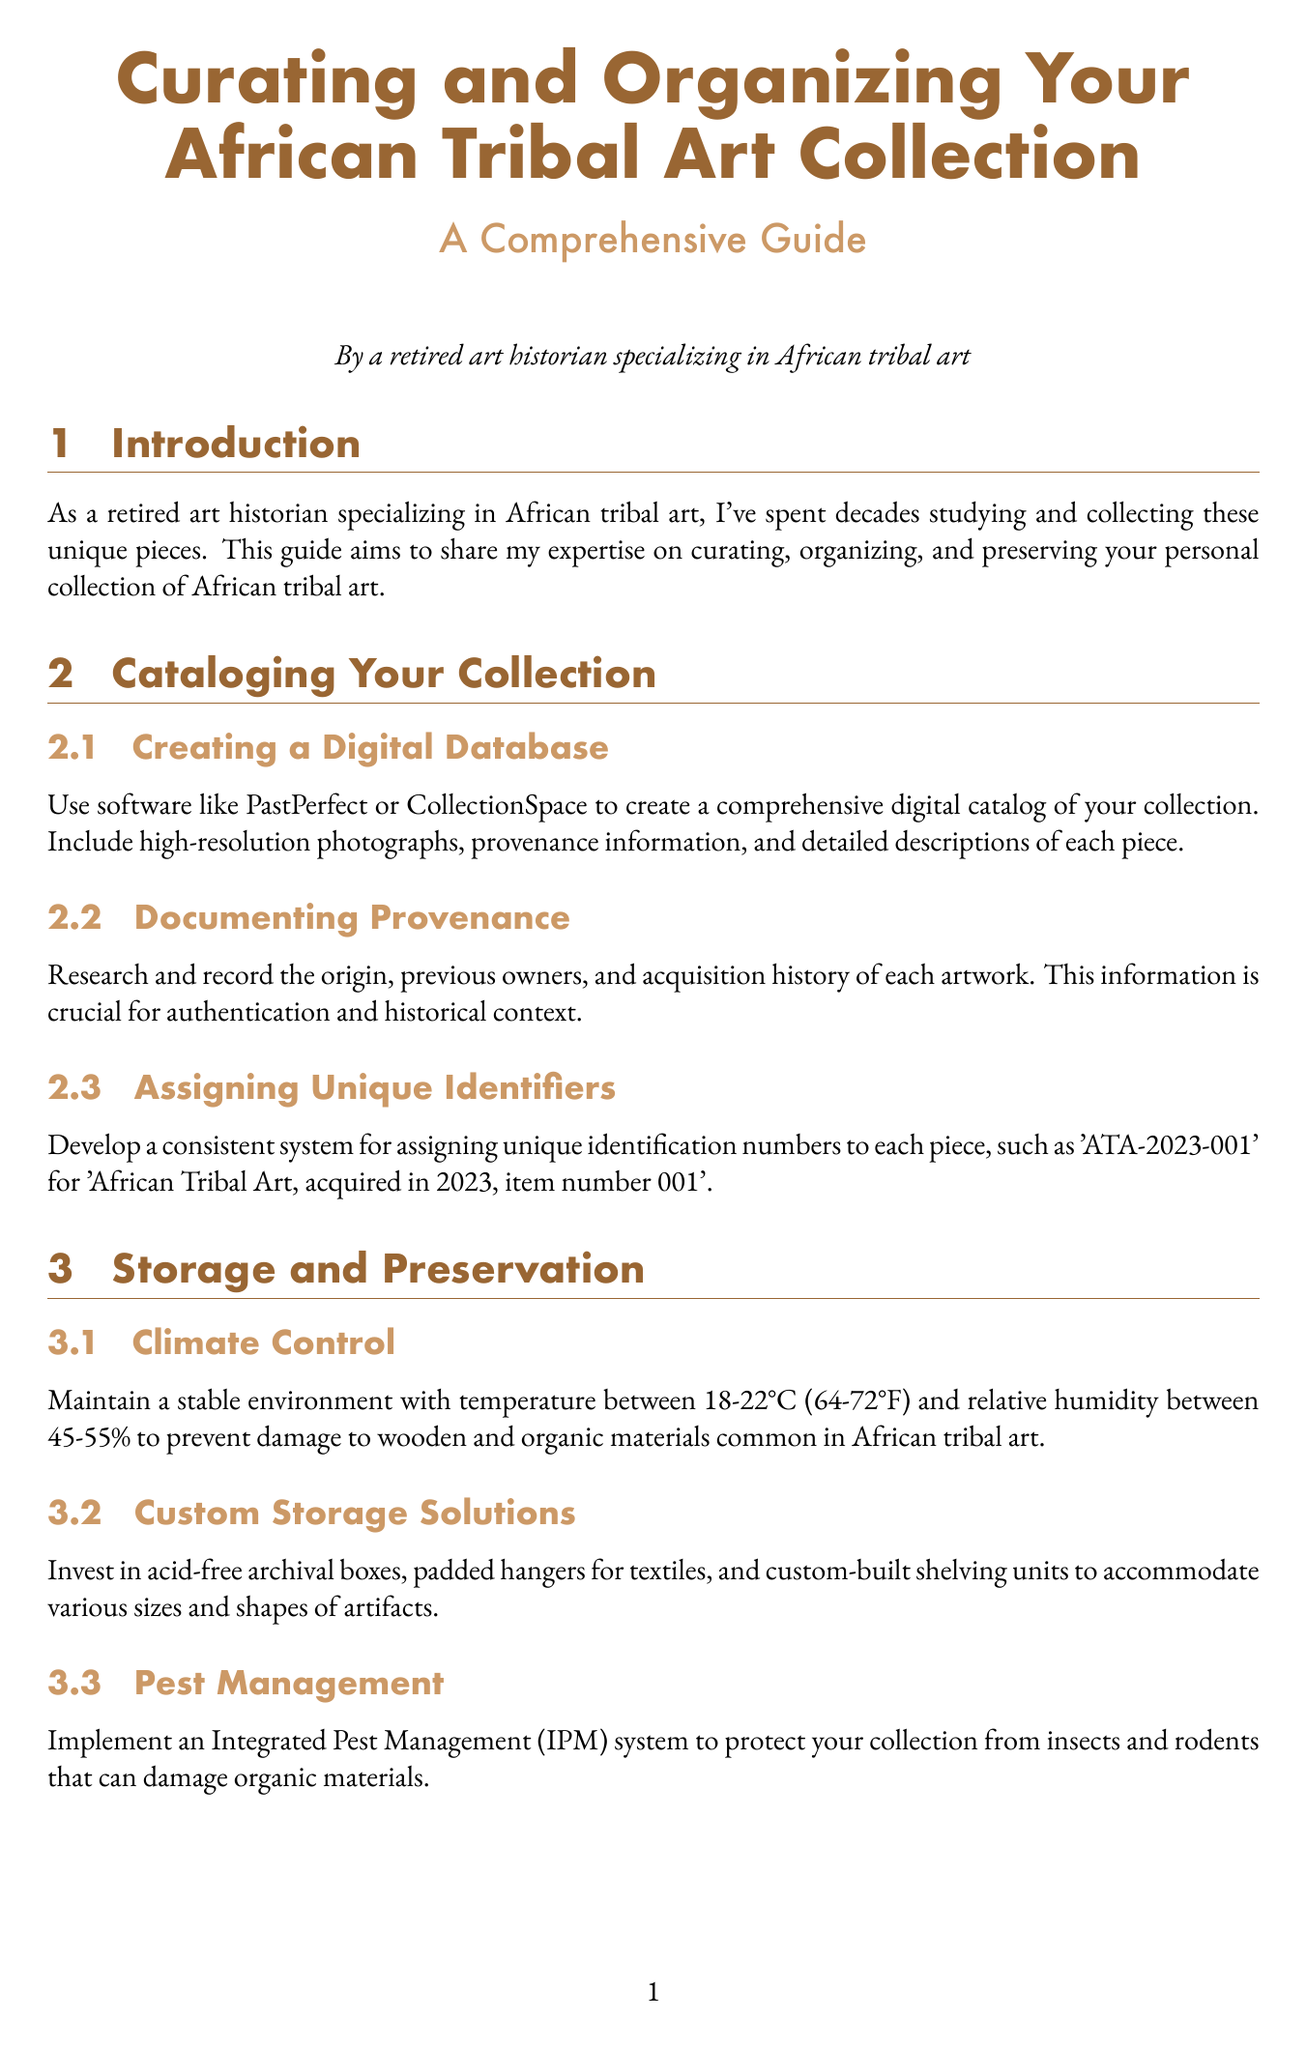What is the title of the manual? The title is the main heading of the document, summarizing its content.
Answer: Curating and Organizing Your African Tribal Art Collection: A Comprehensive Guide What temperature range is recommended for climate control? The document recommends a specific temperature range for preserving art pieces, which is stated in the section on Climate Control.
Answer: 18-22°C What software is suggested for creating a digital catalog? This information is specified in the Cataloging Your Collection section, detailing tools for managing the collection.
Answer: PastPerfect or CollectionSpace What is the recommended illumination level for display? The document provides specific illumination levels for the display of tribal art, mentioned in the Lighting Considerations subsection.
Answer: 50-150 lux Which organization is suggested for professional assessments? This question pertains to conservation practices and is mentioned in the Conservation and Restoration section.
Answer: American Institute for Conservation What is the goal of fostering relationships with museums? The document states the intention behind these partnerships in the Research and Scholarship section.
Answer: Research opportunities and potential loans What should be included in informative labels? This is mentioned in the Cultural Context subsection of the Display Techniques section, highlighting the purpose of labels.
Answer: Cultural context and significance What is the purpose of the conclusion? The conclusion summarizes the main objectives and values of curating and preserving the collection as outlined throughout the document.
Answer: Ensure well-curated, properly preserved collection What does the acronym IPM stand for in pest management? This abbreviation appears in the section on Storage and Preservation, where it refers to a specific management system.
Answer: Integrated Pest Management 